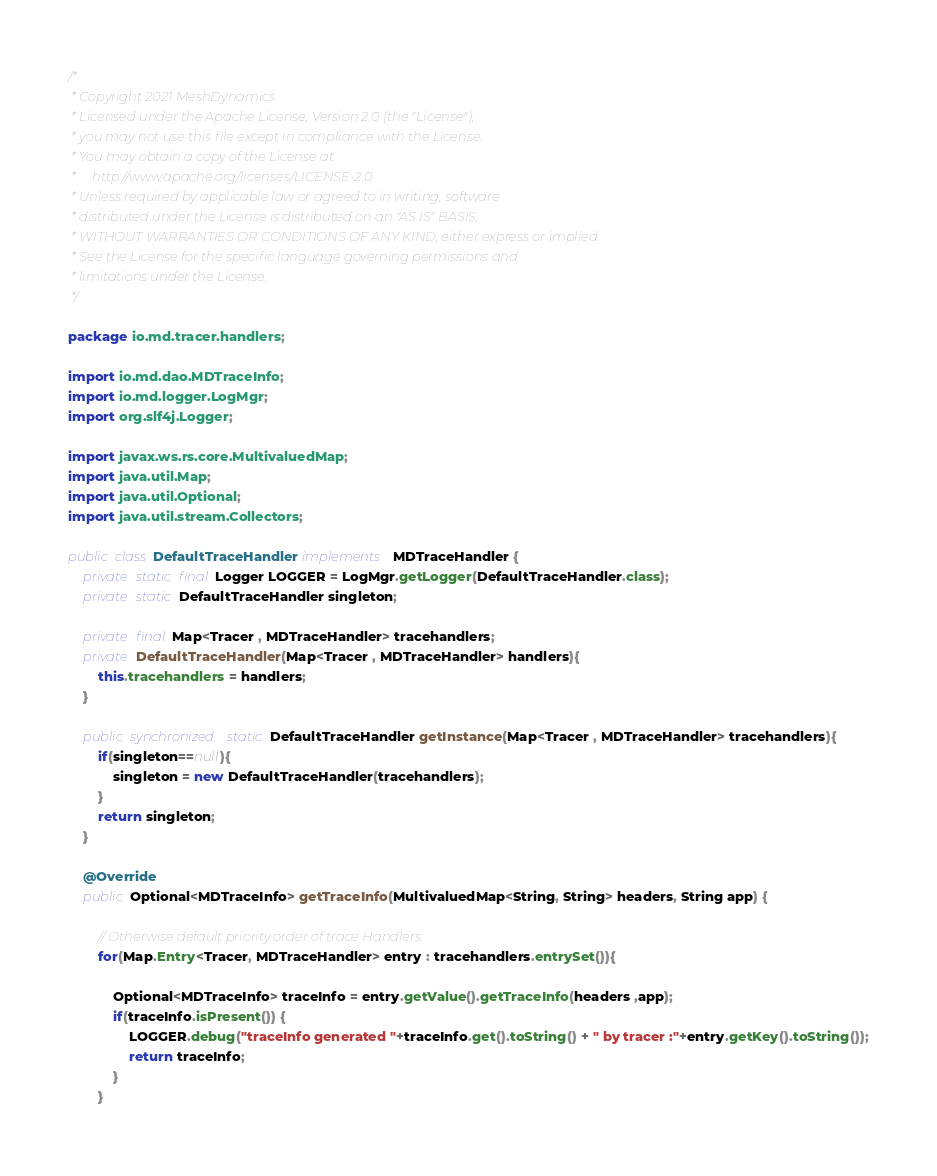<code> <loc_0><loc_0><loc_500><loc_500><_Java_>/*
 * Copyright 2021 MeshDynamics.
 * Licensed under the Apache License, Version 2.0 (the "License");
 * you may not use this file except in compliance with the License.
 * You may obtain a copy of the License at
 *     http://www.apache.org/licenses/LICENSE-2.0
 * Unless required by applicable law or agreed to in writing, software
 * distributed under the License is distributed on an "AS IS" BASIS,
 * WITHOUT WARRANTIES OR CONDITIONS OF ANY KIND, either express or implied.
 * See the License for the specific language governing permissions and
 * limitations under the License.
 */

package io.md.tracer.handlers;

import io.md.dao.MDTraceInfo;
import io.md.logger.LogMgr;
import org.slf4j.Logger;

import javax.ws.rs.core.MultivaluedMap;
import java.util.Map;
import java.util.Optional;
import java.util.stream.Collectors;

public class DefaultTraceHandler implements  MDTraceHandler {
    private static final Logger LOGGER = LogMgr.getLogger(DefaultTraceHandler.class);
    private static DefaultTraceHandler singleton;

    private final Map<Tracer , MDTraceHandler> tracehandlers;
    private DefaultTraceHandler(Map<Tracer , MDTraceHandler> handlers){
        this.tracehandlers = handlers;
    }

    public synchronized static DefaultTraceHandler getInstance(Map<Tracer , MDTraceHandler> tracehandlers){
        if(singleton==null){
            singleton = new DefaultTraceHandler(tracehandlers);
        }
        return singleton;
    }

    @Override
    public Optional<MDTraceInfo> getTraceInfo(MultivaluedMap<String, String> headers, String app) {

        // Otherwise default priority order of trace Handlers.
        for(Map.Entry<Tracer, MDTraceHandler> entry : tracehandlers.entrySet()){

            Optional<MDTraceInfo> traceInfo = entry.getValue().getTraceInfo(headers ,app);
            if(traceInfo.isPresent()) {
                LOGGER.debug("traceInfo generated "+traceInfo.get().toString() + " by tracer :"+entry.getKey().toString());
                return traceInfo;
            }
        }
</code> 